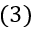<formula> <loc_0><loc_0><loc_500><loc_500>( 3 )</formula> 